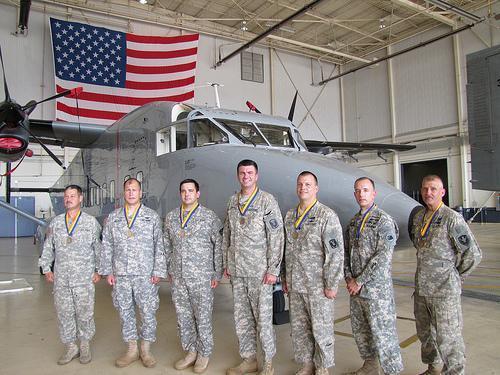How many propellers does the plane appear to have?
Give a very brief answer. 2. 